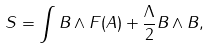<formula> <loc_0><loc_0><loc_500><loc_500>S = \int B \wedge F ( A ) + \frac { \Lambda } { 2 } B \wedge B ,</formula> 